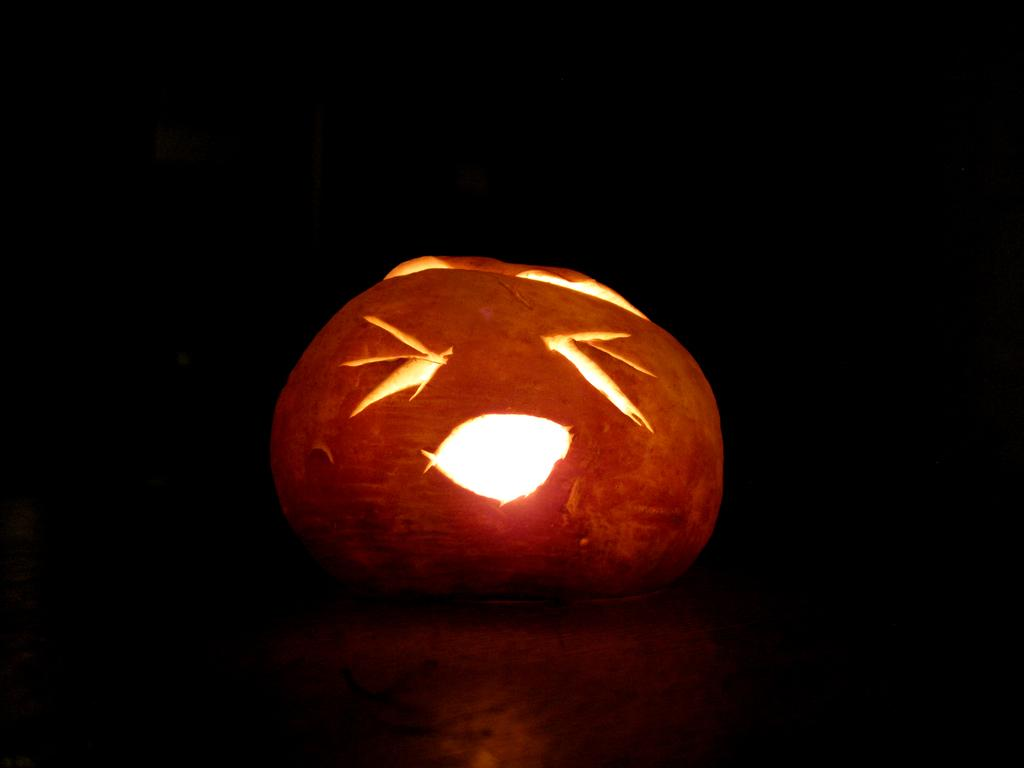What is the main subject in the center of the image? There is a halloween pumpkin in the center of the image. How would you describe the overall lighting in the image? The background of the image is dark. What type of swing can be seen in the image? There is no swing present in the image. What color are the trousers worn by the pumpkin in the image? The image features a halloween pumpkin, which is not a person and does not wear trousers. 